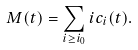Convert formula to latex. <formula><loc_0><loc_0><loc_500><loc_500>M ( t ) = \sum _ { i \geq i _ { 0 } } i c _ { i } ( t ) .</formula> 